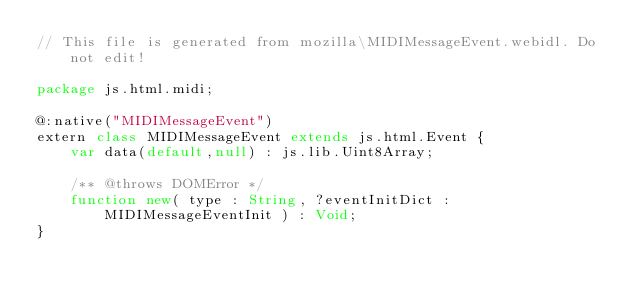Convert code to text. <code><loc_0><loc_0><loc_500><loc_500><_Haxe_>// This file is generated from mozilla\MIDIMessageEvent.webidl. Do not edit!

package js.html.midi;

@:native("MIDIMessageEvent")
extern class MIDIMessageEvent extends js.html.Event {
	var data(default,null) : js.lib.Uint8Array;
	
	/** @throws DOMError */
	function new( type : String, ?eventInitDict : MIDIMessageEventInit ) : Void;
}</code> 